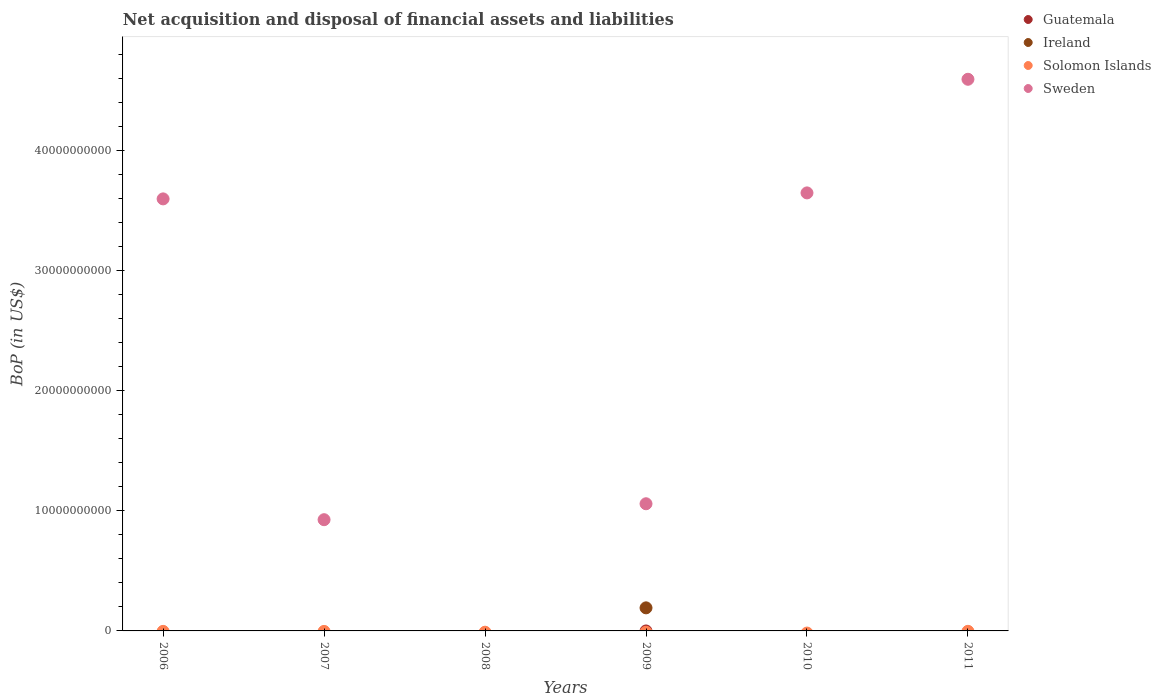What is the Balance of Payments in Sweden in 2007?
Offer a very short reply. 9.27e+09. Across all years, what is the maximum Balance of Payments in Ireland?
Give a very brief answer. 1.92e+09. In which year was the Balance of Payments in Ireland maximum?
Your answer should be compact. 2009. What is the total Balance of Payments in Sweden in the graph?
Keep it short and to the point. 1.38e+11. What is the difference between the Balance of Payments in Sweden in 2007 and that in 2010?
Your response must be concise. -2.72e+1. What is the difference between the Balance of Payments in Ireland in 2011 and the Balance of Payments in Sweden in 2009?
Provide a succinct answer. -1.06e+1. What is the difference between the highest and the second highest Balance of Payments in Sweden?
Make the answer very short. 9.47e+09. What is the difference between the highest and the lowest Balance of Payments in Sweden?
Make the answer very short. 4.60e+1. In how many years, is the Balance of Payments in Sweden greater than the average Balance of Payments in Sweden taken over all years?
Provide a succinct answer. 3. Does the Balance of Payments in Solomon Islands monotonically increase over the years?
Provide a succinct answer. No. Is the Balance of Payments in Guatemala strictly greater than the Balance of Payments in Solomon Islands over the years?
Provide a short and direct response. No. Is the Balance of Payments in Solomon Islands strictly less than the Balance of Payments in Guatemala over the years?
Make the answer very short. No. How many years are there in the graph?
Your answer should be very brief. 6. What is the difference between two consecutive major ticks on the Y-axis?
Offer a terse response. 1.00e+1. Are the values on the major ticks of Y-axis written in scientific E-notation?
Keep it short and to the point. No. Where does the legend appear in the graph?
Ensure brevity in your answer.  Top right. What is the title of the graph?
Ensure brevity in your answer.  Net acquisition and disposal of financial assets and liabilities. Does "Middle income" appear as one of the legend labels in the graph?
Your response must be concise. No. What is the label or title of the X-axis?
Give a very brief answer. Years. What is the label or title of the Y-axis?
Your answer should be compact. BoP (in US$). What is the BoP (in US$) in Ireland in 2006?
Give a very brief answer. 0. What is the BoP (in US$) in Sweden in 2006?
Make the answer very short. 3.60e+1. What is the BoP (in US$) in Guatemala in 2007?
Make the answer very short. 0. What is the BoP (in US$) of Ireland in 2007?
Make the answer very short. 0. What is the BoP (in US$) in Solomon Islands in 2007?
Provide a succinct answer. 0. What is the BoP (in US$) in Sweden in 2007?
Offer a terse response. 9.27e+09. What is the BoP (in US$) in Ireland in 2009?
Offer a terse response. 1.92e+09. What is the BoP (in US$) in Solomon Islands in 2009?
Make the answer very short. 0. What is the BoP (in US$) in Sweden in 2009?
Provide a succinct answer. 1.06e+1. What is the BoP (in US$) in Guatemala in 2010?
Provide a short and direct response. 0. What is the BoP (in US$) of Solomon Islands in 2010?
Provide a short and direct response. 0. What is the BoP (in US$) of Sweden in 2010?
Provide a succinct answer. 3.65e+1. What is the BoP (in US$) in Guatemala in 2011?
Offer a very short reply. 0. What is the BoP (in US$) of Ireland in 2011?
Make the answer very short. 0. What is the BoP (in US$) of Sweden in 2011?
Keep it short and to the point. 4.60e+1. Across all years, what is the maximum BoP (in US$) of Ireland?
Give a very brief answer. 1.92e+09. Across all years, what is the maximum BoP (in US$) in Sweden?
Your response must be concise. 4.60e+1. Across all years, what is the minimum BoP (in US$) of Ireland?
Ensure brevity in your answer.  0. What is the total BoP (in US$) in Guatemala in the graph?
Provide a short and direct response. 0. What is the total BoP (in US$) in Ireland in the graph?
Your answer should be very brief. 1.92e+09. What is the total BoP (in US$) of Sweden in the graph?
Provide a short and direct response. 1.38e+11. What is the difference between the BoP (in US$) in Sweden in 2006 and that in 2007?
Ensure brevity in your answer.  2.67e+1. What is the difference between the BoP (in US$) in Sweden in 2006 and that in 2009?
Your answer should be compact. 2.54e+1. What is the difference between the BoP (in US$) of Sweden in 2006 and that in 2010?
Provide a succinct answer. -4.99e+08. What is the difference between the BoP (in US$) in Sweden in 2006 and that in 2011?
Ensure brevity in your answer.  -9.97e+09. What is the difference between the BoP (in US$) in Sweden in 2007 and that in 2009?
Your response must be concise. -1.33e+09. What is the difference between the BoP (in US$) in Sweden in 2007 and that in 2010?
Your response must be concise. -2.72e+1. What is the difference between the BoP (in US$) of Sweden in 2007 and that in 2011?
Offer a very short reply. -3.67e+1. What is the difference between the BoP (in US$) of Sweden in 2009 and that in 2010?
Keep it short and to the point. -2.59e+1. What is the difference between the BoP (in US$) of Sweden in 2009 and that in 2011?
Offer a very short reply. -3.54e+1. What is the difference between the BoP (in US$) in Sweden in 2010 and that in 2011?
Keep it short and to the point. -9.47e+09. What is the difference between the BoP (in US$) in Ireland in 2009 and the BoP (in US$) in Sweden in 2010?
Ensure brevity in your answer.  -3.46e+1. What is the difference between the BoP (in US$) in Ireland in 2009 and the BoP (in US$) in Sweden in 2011?
Offer a terse response. -4.41e+1. What is the average BoP (in US$) of Ireland per year?
Give a very brief answer. 3.20e+08. What is the average BoP (in US$) in Sweden per year?
Provide a short and direct response. 2.31e+1. In the year 2009, what is the difference between the BoP (in US$) in Ireland and BoP (in US$) in Sweden?
Offer a terse response. -8.68e+09. What is the ratio of the BoP (in US$) of Sweden in 2006 to that in 2007?
Give a very brief answer. 3.88. What is the ratio of the BoP (in US$) of Sweden in 2006 to that in 2009?
Give a very brief answer. 3.4. What is the ratio of the BoP (in US$) of Sweden in 2006 to that in 2010?
Give a very brief answer. 0.99. What is the ratio of the BoP (in US$) of Sweden in 2006 to that in 2011?
Keep it short and to the point. 0.78. What is the ratio of the BoP (in US$) of Sweden in 2007 to that in 2009?
Your answer should be very brief. 0.87. What is the ratio of the BoP (in US$) in Sweden in 2007 to that in 2010?
Your answer should be very brief. 0.25. What is the ratio of the BoP (in US$) of Sweden in 2007 to that in 2011?
Offer a very short reply. 0.2. What is the ratio of the BoP (in US$) of Sweden in 2009 to that in 2010?
Give a very brief answer. 0.29. What is the ratio of the BoP (in US$) of Sweden in 2009 to that in 2011?
Your response must be concise. 0.23. What is the ratio of the BoP (in US$) in Sweden in 2010 to that in 2011?
Your response must be concise. 0.79. What is the difference between the highest and the second highest BoP (in US$) in Sweden?
Keep it short and to the point. 9.47e+09. What is the difference between the highest and the lowest BoP (in US$) of Ireland?
Make the answer very short. 1.92e+09. What is the difference between the highest and the lowest BoP (in US$) in Sweden?
Provide a succinct answer. 4.60e+1. 